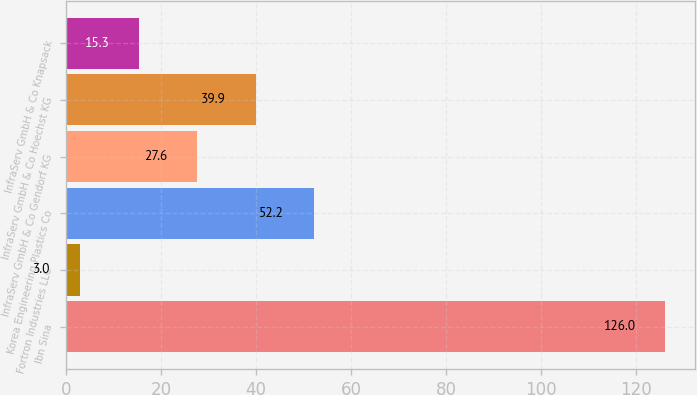<chart> <loc_0><loc_0><loc_500><loc_500><bar_chart><fcel>Ibn Sina<fcel>Fortron Industries LLC<fcel>Korea Engineering Plastics Co<fcel>InfraServ GmbH & Co Gendorf KG<fcel>InfraServ GmbH & Co Hoechst KG<fcel>InfraServ GmbH & Co Knapsack<nl><fcel>126<fcel>3<fcel>52.2<fcel>27.6<fcel>39.9<fcel>15.3<nl></chart> 